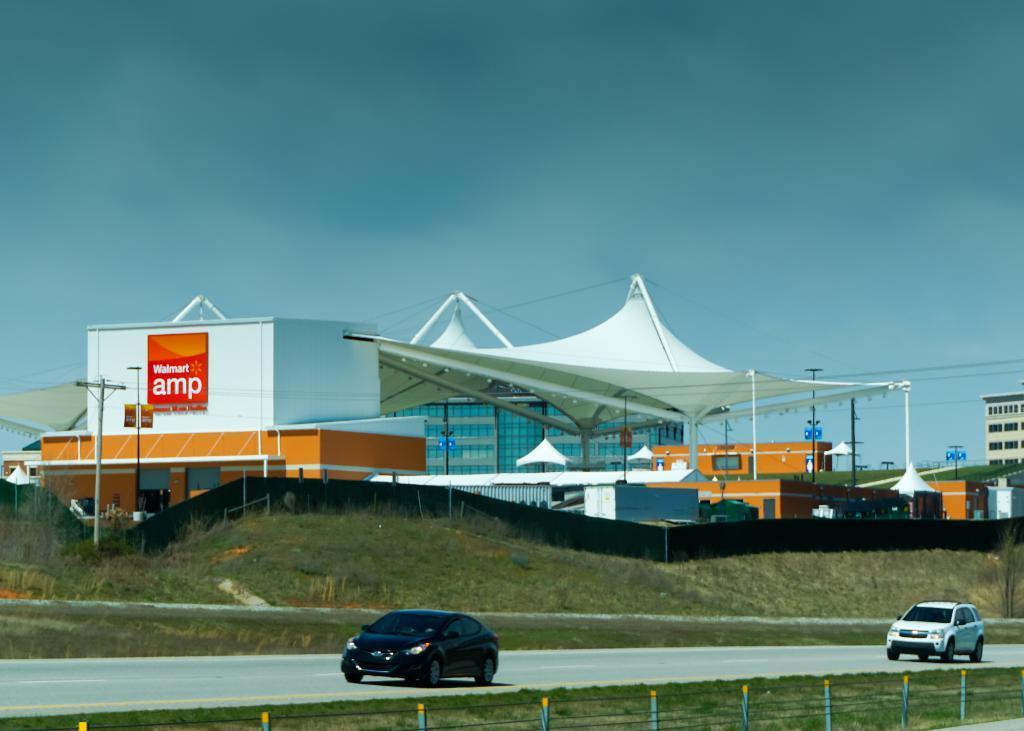Could you give a brief overview of what you see in this image? In the image we can see there are buildings. Here we can see the tent and the poster. There is even an electric pole with electric wires. There are vehicles on the road. Here we can see grass, fence and the trees. 